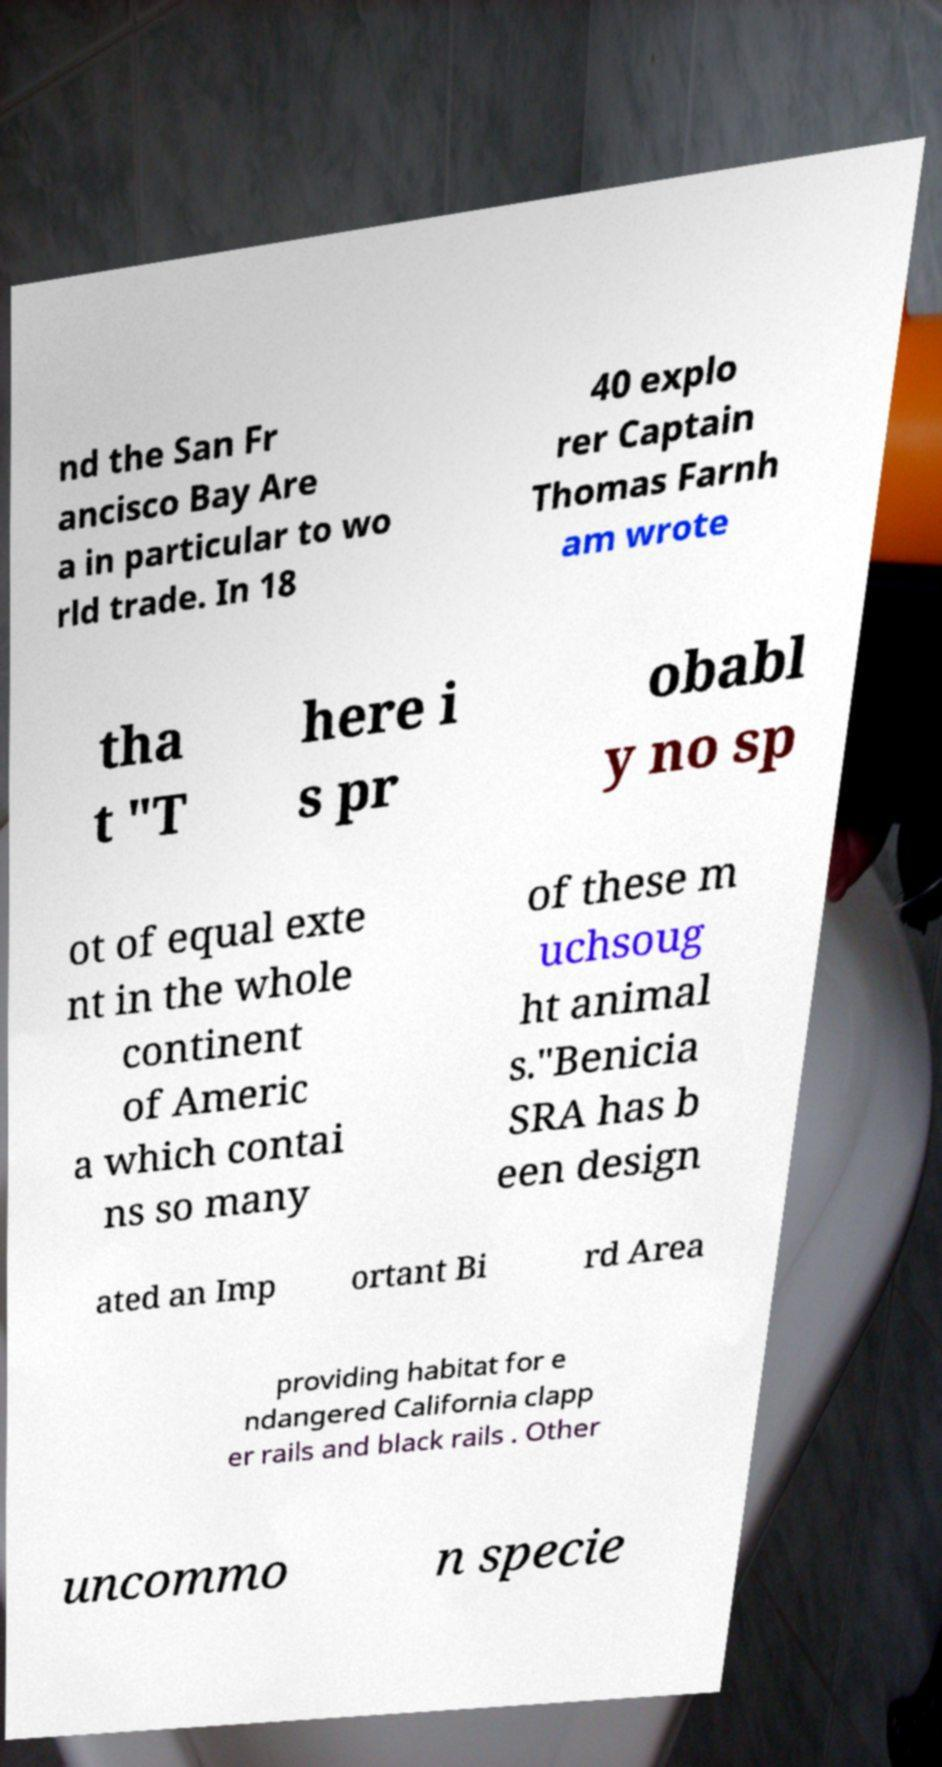Can you read and provide the text displayed in the image?This photo seems to have some interesting text. Can you extract and type it out for me? nd the San Fr ancisco Bay Are a in particular to wo rld trade. In 18 40 explo rer Captain Thomas Farnh am wrote tha t "T here i s pr obabl y no sp ot of equal exte nt in the whole continent of Americ a which contai ns so many of these m uchsoug ht animal s."Benicia SRA has b een design ated an Imp ortant Bi rd Area providing habitat for e ndangered California clapp er rails and black rails . Other uncommo n specie 